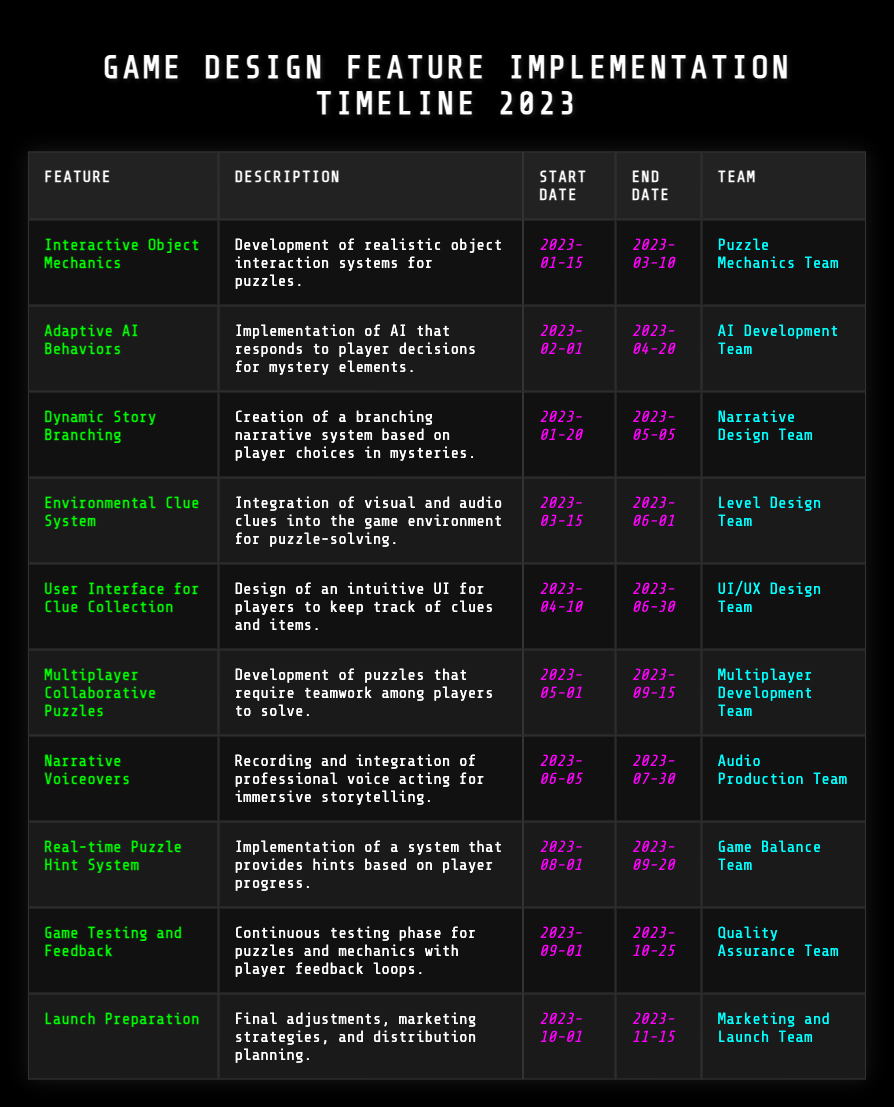What is the feature that has the longest implementation period? To find the longest implementation period, calculate the duration for each feature by subtracting the start date from the end date. The "Dynamic Story Branching" spans from January 20 to May 5, totaling 105 days. "Multiplayer Collaborative Puzzles" lasts from May 1 to September 15, which is 136 days. Thus, it has the longest period.
Answer: Multiplayer Collaborative Puzzles Which team is responsible for the "User Interface for Clue Collection"? The table specifically lists the team responsible for each feature. For "User Interface for Clue Collection", the team is identified as the "UI/UX Design Team."
Answer: UI/UX Design Team How many features are implemented between March and June 2023? Review the start and end dates of the features. "Interactive Object Mechanics," "Environmental Clue System," "User Interface for Clue Collection," and "Multiplayer Collaborative Puzzles" fall within the March to June range, totaling four features.
Answer: 4 Is there any feature that will finish before April 2023? By checking the end dates, "Interactive Object Mechanics" ends on March 10 and "Adaptive AI Behaviors" ends on April 20. Since one ends before April, the answer is yes.
Answer: Yes Which feature was worked on by the Audio Production Team? The table states that "Narrative Voiceovers" is the feature overseen by the Audio Production Team.
Answer: Narrative Voiceovers What is the duration of the "Real-time Puzzle Hint System" implementation? The implementation of the "Real-time Puzzle Hint System" starts on August 1 and ends on September 20, which is a duration of 50 days (August: 31 days - 1 = 30 + September: 20 days).
Answer: 50 days How many total features begin in the first half of the year (January to June)? Counting the features that start from January to June: "Interactive Object Mechanics," "Dynamic Story Branching," "Adaptive AI Behaviors," "Environmental Clue System," "User Interface for Clue Collection," and "Narrative Voiceovers" accounts for six features.
Answer: 6 What is the earliest starting feature listed in the table? The table indicates that "Interactive Object Mechanics" has the earliest start date of January 15, 2023.
Answer: Interactive Object Mechanics Which feature is scheduled to be implemented last? The last implementation is "Launch Preparation," scheduled to end on November 15, 2023.
Answer: Launch Preparation Did any feature have a start date in March 2023? Checking the start dates, "Environmental Clue System" begins on March 15, confirming that at least one feature started then.
Answer: Yes 